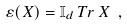Convert formula to latex. <formula><loc_0><loc_0><loc_500><loc_500>\varepsilon ( X ) = \mathbb { I } _ { d } \, T r \, X \ ,</formula> 